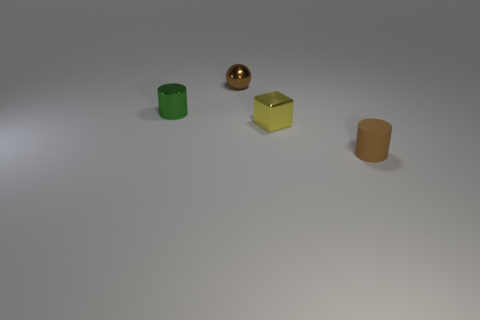How many other objects are the same size as the green cylinder?
Ensure brevity in your answer.  3. Do the small cylinder behind the rubber thing and the small brown thing that is in front of the small green thing have the same material?
Offer a terse response. No. The shiny cube that is the same size as the brown metal object is what color?
Provide a succinct answer. Yellow. Is there any other thing that is the same color as the metal ball?
Your answer should be compact. Yes. What is the size of the brown object that is in front of the brown object on the left side of the cylinder in front of the green cylinder?
Your answer should be compact. Small. What is the color of the metallic object that is behind the yellow block and in front of the small brown metal object?
Give a very brief answer. Green. What is the size of the metal object that is in front of the small green cylinder?
Your answer should be compact. Small. What number of small cubes have the same material as the yellow thing?
Your answer should be very brief. 0. What shape is the small metallic thing that is the same color as the rubber cylinder?
Ensure brevity in your answer.  Sphere. There is a tiny brown object in front of the brown ball; is it the same shape as the small green object?
Your answer should be very brief. Yes. 